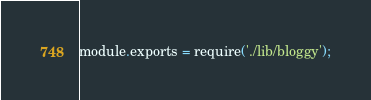<code> <loc_0><loc_0><loc_500><loc_500><_JavaScript_>module.exports = require('./lib/bloggy');</code> 